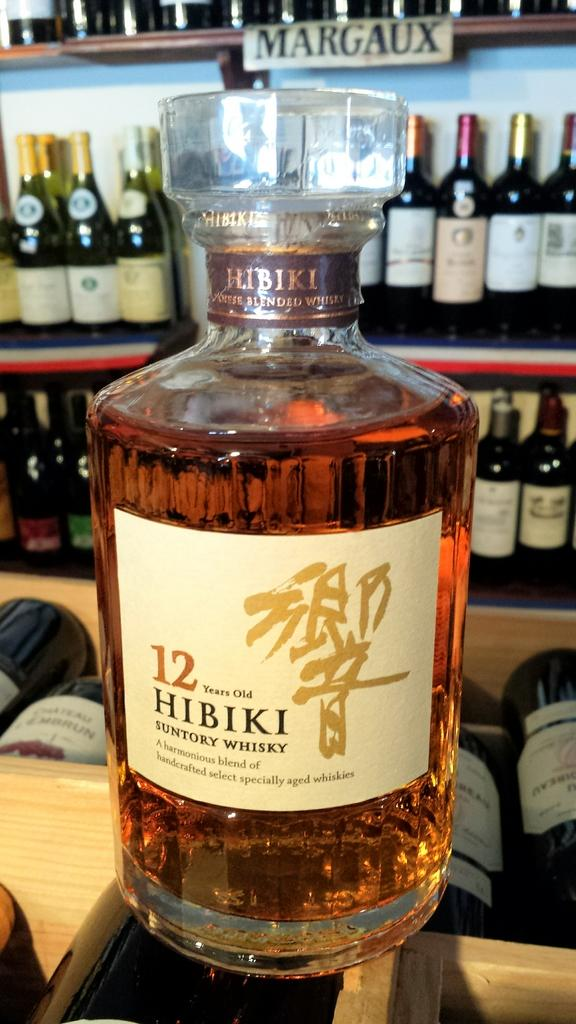<image>
Present a compact description of the photo's key features. The alcoholic beverage in the glass bottle is 12 years old. 